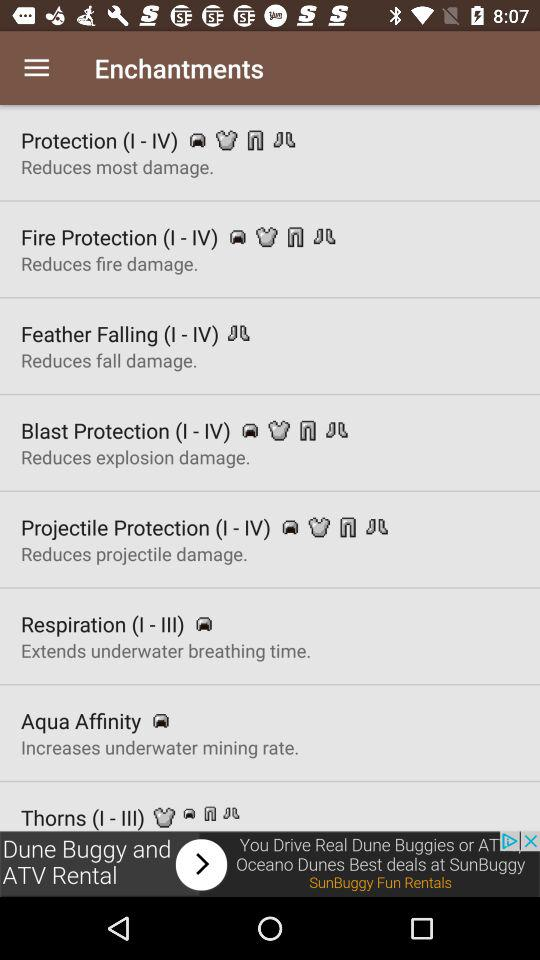Why is fire protection used? Fire protection is used to "Reduces fire damage.". 